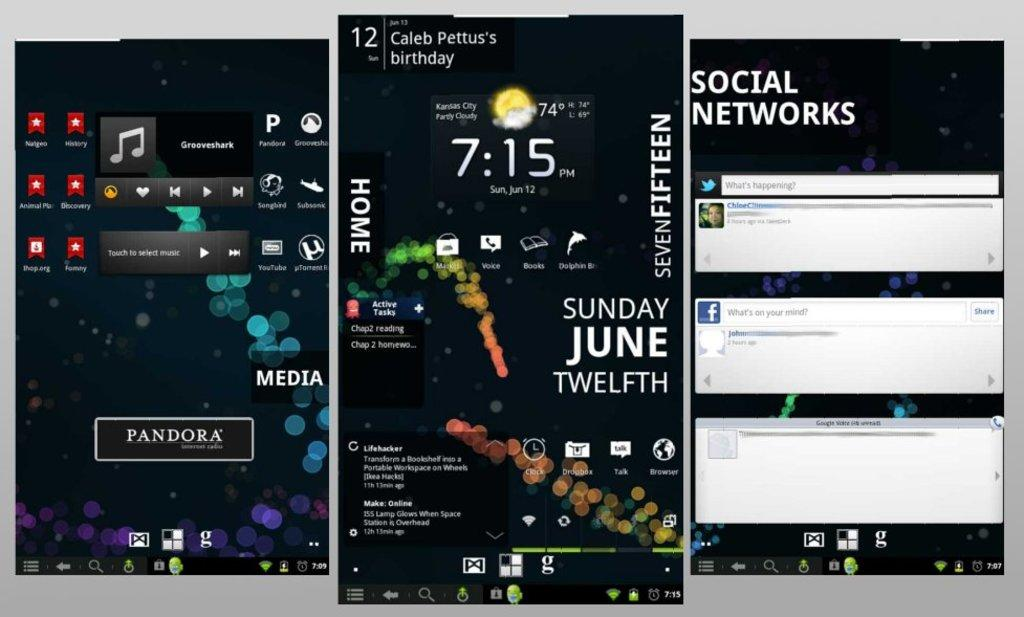<image>
Offer a succinct explanation of the picture presented. Phone applications shown in three different windows with different things pulled up 